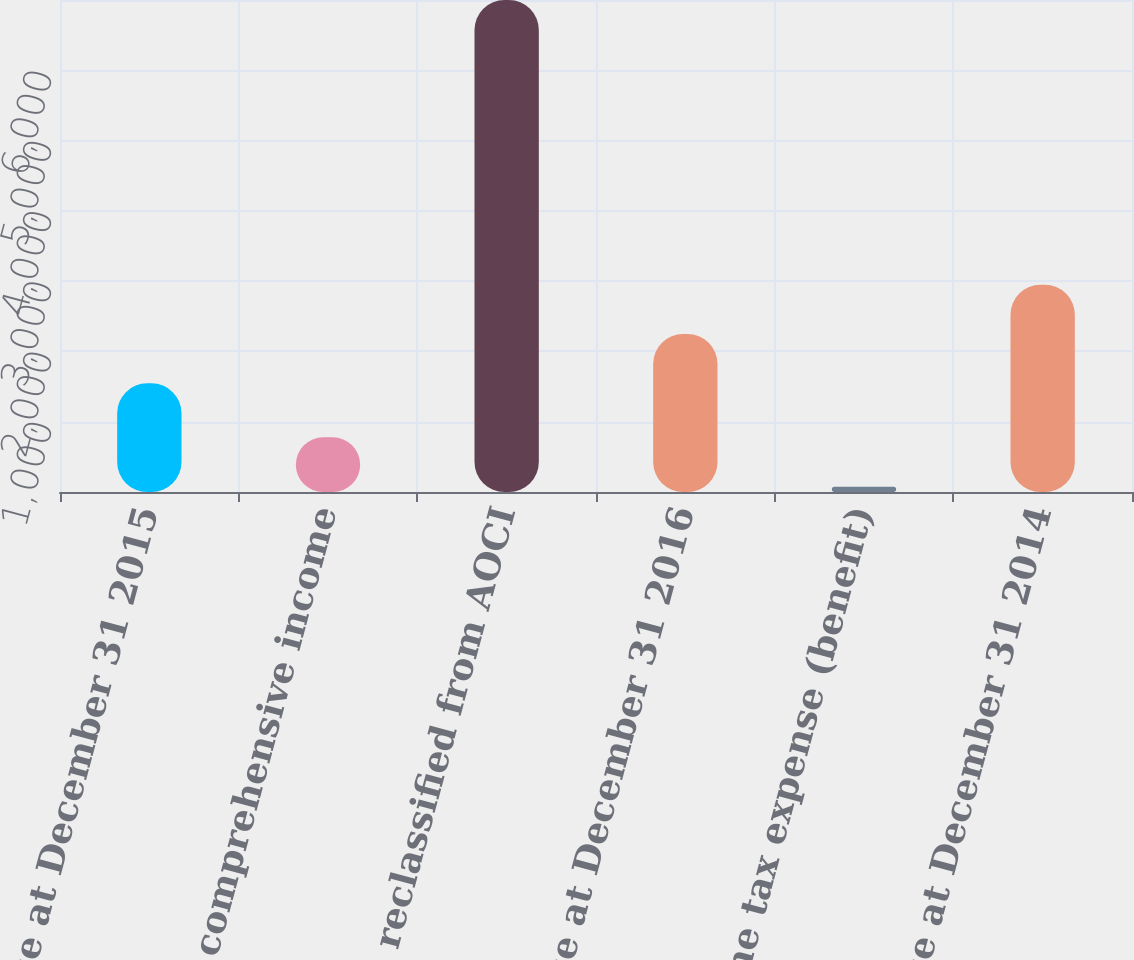Convert chart. <chart><loc_0><loc_0><loc_500><loc_500><bar_chart><fcel>Balance at December 31 2015<fcel>Other comprehensive income<fcel>Amounts reclassified from AOCI<fcel>Balance at December 31 2016<fcel>Income tax expense (benefit)<fcel>Balance at December 31 2014<nl><fcel>1546<fcel>777.7<fcel>7000<fcel>2247.7<fcel>76<fcel>2949.4<nl></chart> 